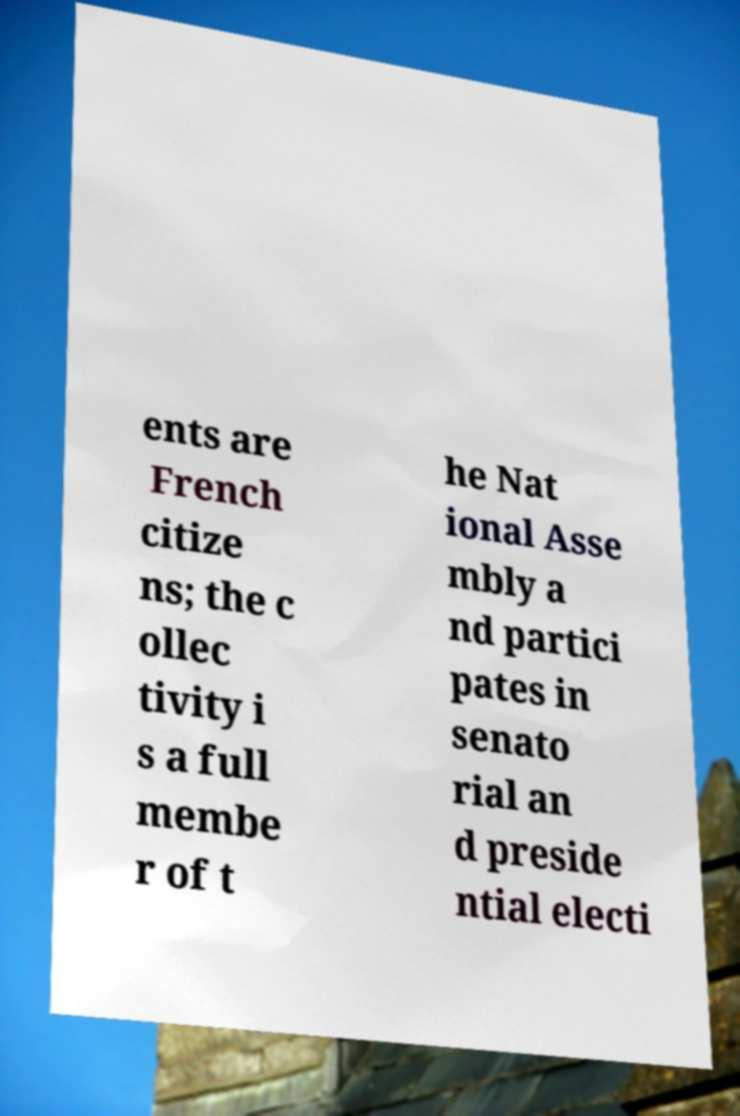Could you extract and type out the text from this image? ents are French citize ns; the c ollec tivity i s a full membe r of t he Nat ional Asse mbly a nd partici pates in senato rial an d preside ntial electi 